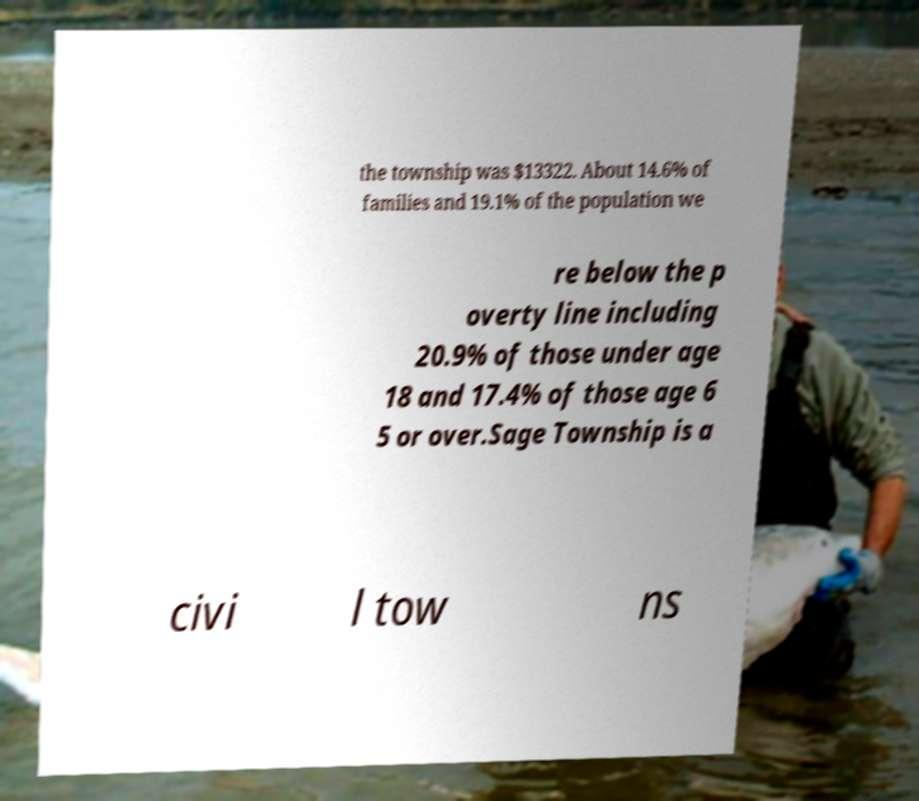Please read and relay the text visible in this image. What does it say? the township was $13322. About 14.6% of families and 19.1% of the population we re below the p overty line including 20.9% of those under age 18 and 17.4% of those age 6 5 or over.Sage Township is a civi l tow ns 